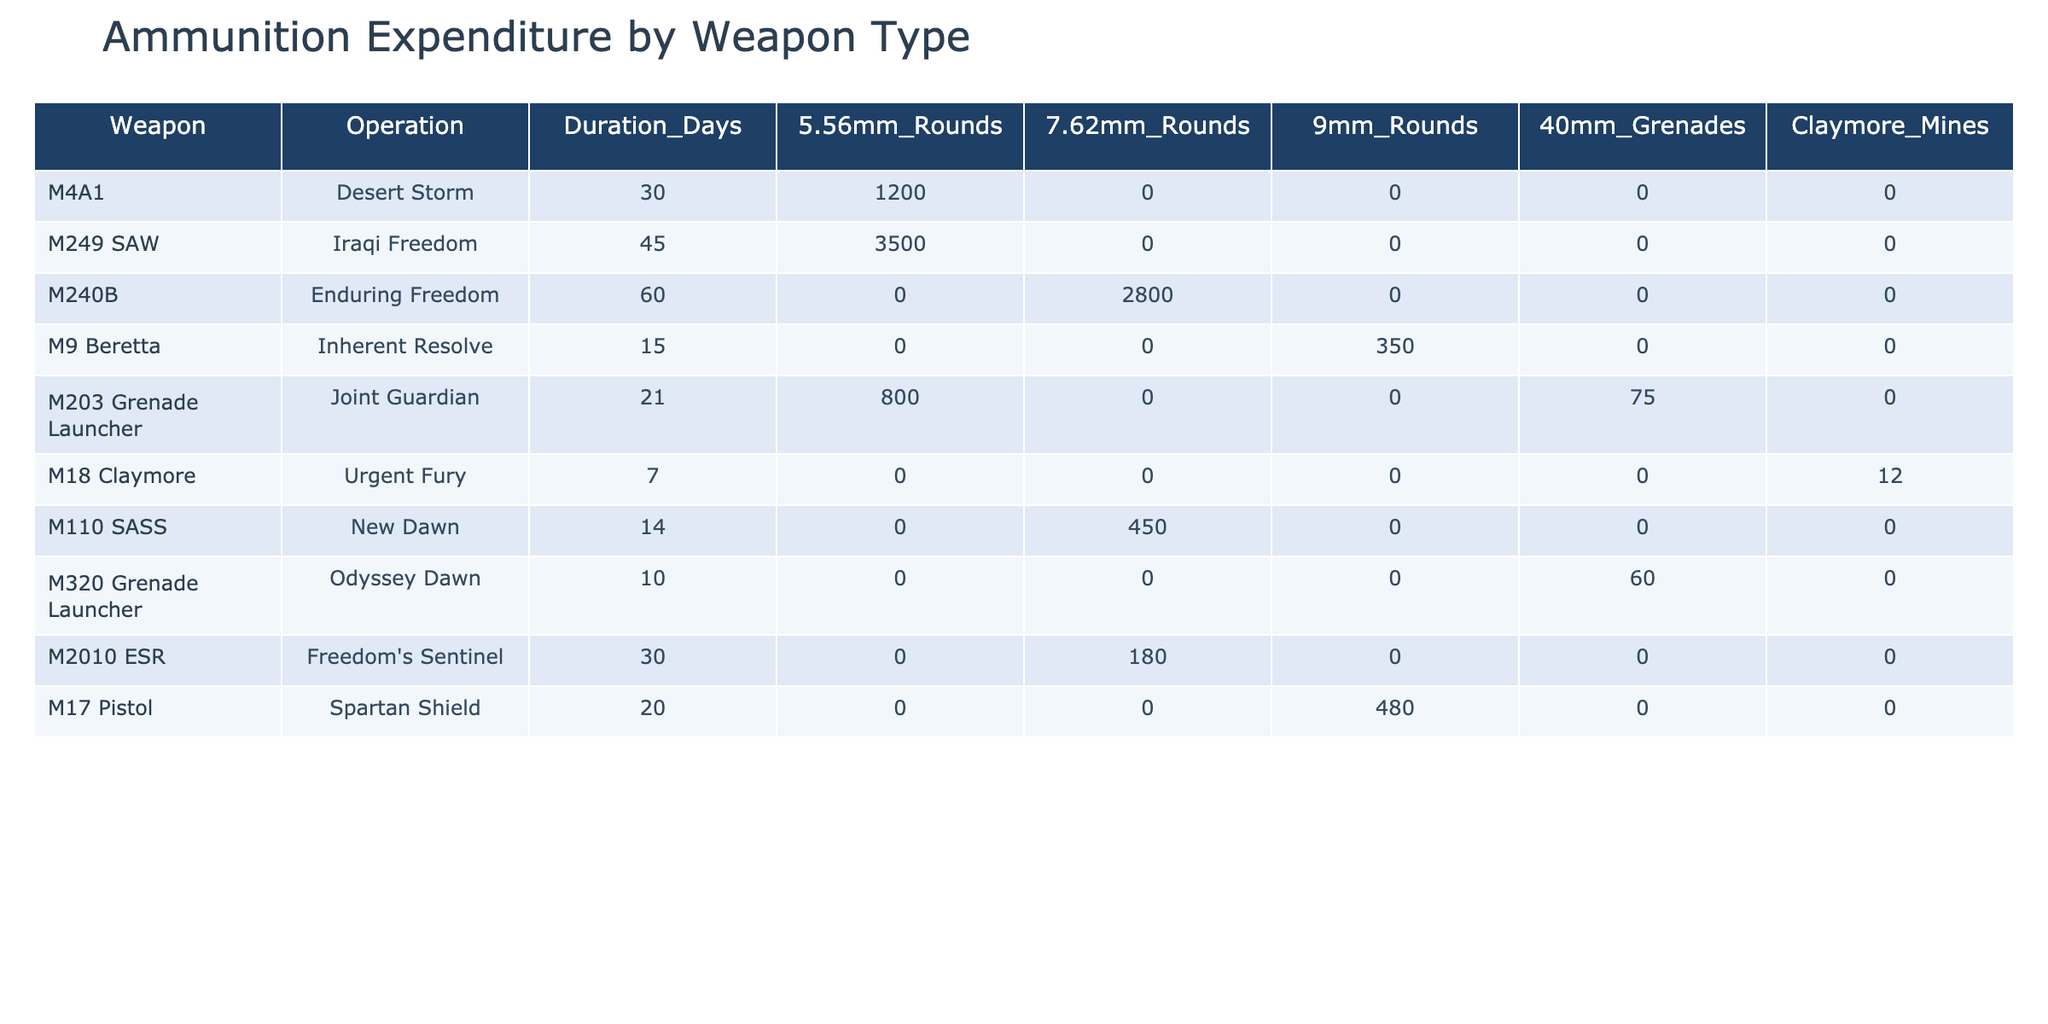What is the total expenditure of 5.56mm rounds? To find the total expenditure of 5.56mm rounds, we sum the values from the corresponding column: 1200 (M4A1) + 3500 (M249 SAW) + 800 (M203 Grenade Launcher) = 5500.
Answer: 5500 Which weapon had the highest expenditure of 7.62mm rounds? The table shows that the M240B had the highest expenditure of 7.62mm rounds at 2800.
Answer: M240B Did any weapon use Claymore Mines during field operations? Looking at the Claymore Mines column, the M18 Claymore used 12, indicating that yes, a weapon did use Claymore Mines.
Answer: Yes What is the average expenditure of 9mm rounds across all operations? To find the average, we sum the 9mm rounds (350 from M9 Beretta + 480 from M17 Pistol = 830) and then divide by the number of weapons that used it (2). So, 830 / 2 = 415.
Answer: 415 Which operation had the longest duration, and how many rounds were used in 40mm grenades during that operation? The longest operation is Iraqi Freedom (45 days), and during this operation, 0 rounds of 40mm grenades were used.
Answer: 0 If we consider all operations, what is the total number of ammunition rounds used across all types? First, we calculate the total rounds for each type: 1200 + 3500 + 0 + 0 + 800 + 0 + 0 + 0 + 0 + 0 = 5500 for 5.56mm; 0 + 2800 + 0 + 0 + 0 + 0 + 450 + 0 + 180 + 0 = 3430 for 7.62mm; 0 + 0 + 0 + 350 + 0 + 0 + 0 + 480 + 0 + 0 = 830 for 9mm; 0 + 0 + 75 + 60 + 0 + 0 + 0 + 0 + 0 + 0 = 135 for 40mm grenades; and 12 for Claymore Mines. Adding all gives us 5500 + 3430 + 830 + 135 + 12 = 9925.
Answer: 9925 How many different types of weapons used 40mm grenades? The table shows that only the M203 Grenade Launcher and M320 Grenade Launcher used 40mm grenades, which counts as 2 different weapon types.
Answer: 2 Which operation used a total of 0 rounds for all types of ammunition? Reviewing the operations, the M240B used 0 rounds of 5.56mm, 9mm, and 40mm grenades but did use 2800 of 7.62mm. However, no operations show 0 rounds for all types; therefore, none used 0 rounds across all types.
Answer: None 